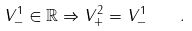Convert formula to latex. <formula><loc_0><loc_0><loc_500><loc_500>V _ { - } ^ { 1 } \in \mathbb { R } \Rightarrow V _ { + } ^ { 2 } = V _ { - } ^ { 1 } \quad .</formula> 